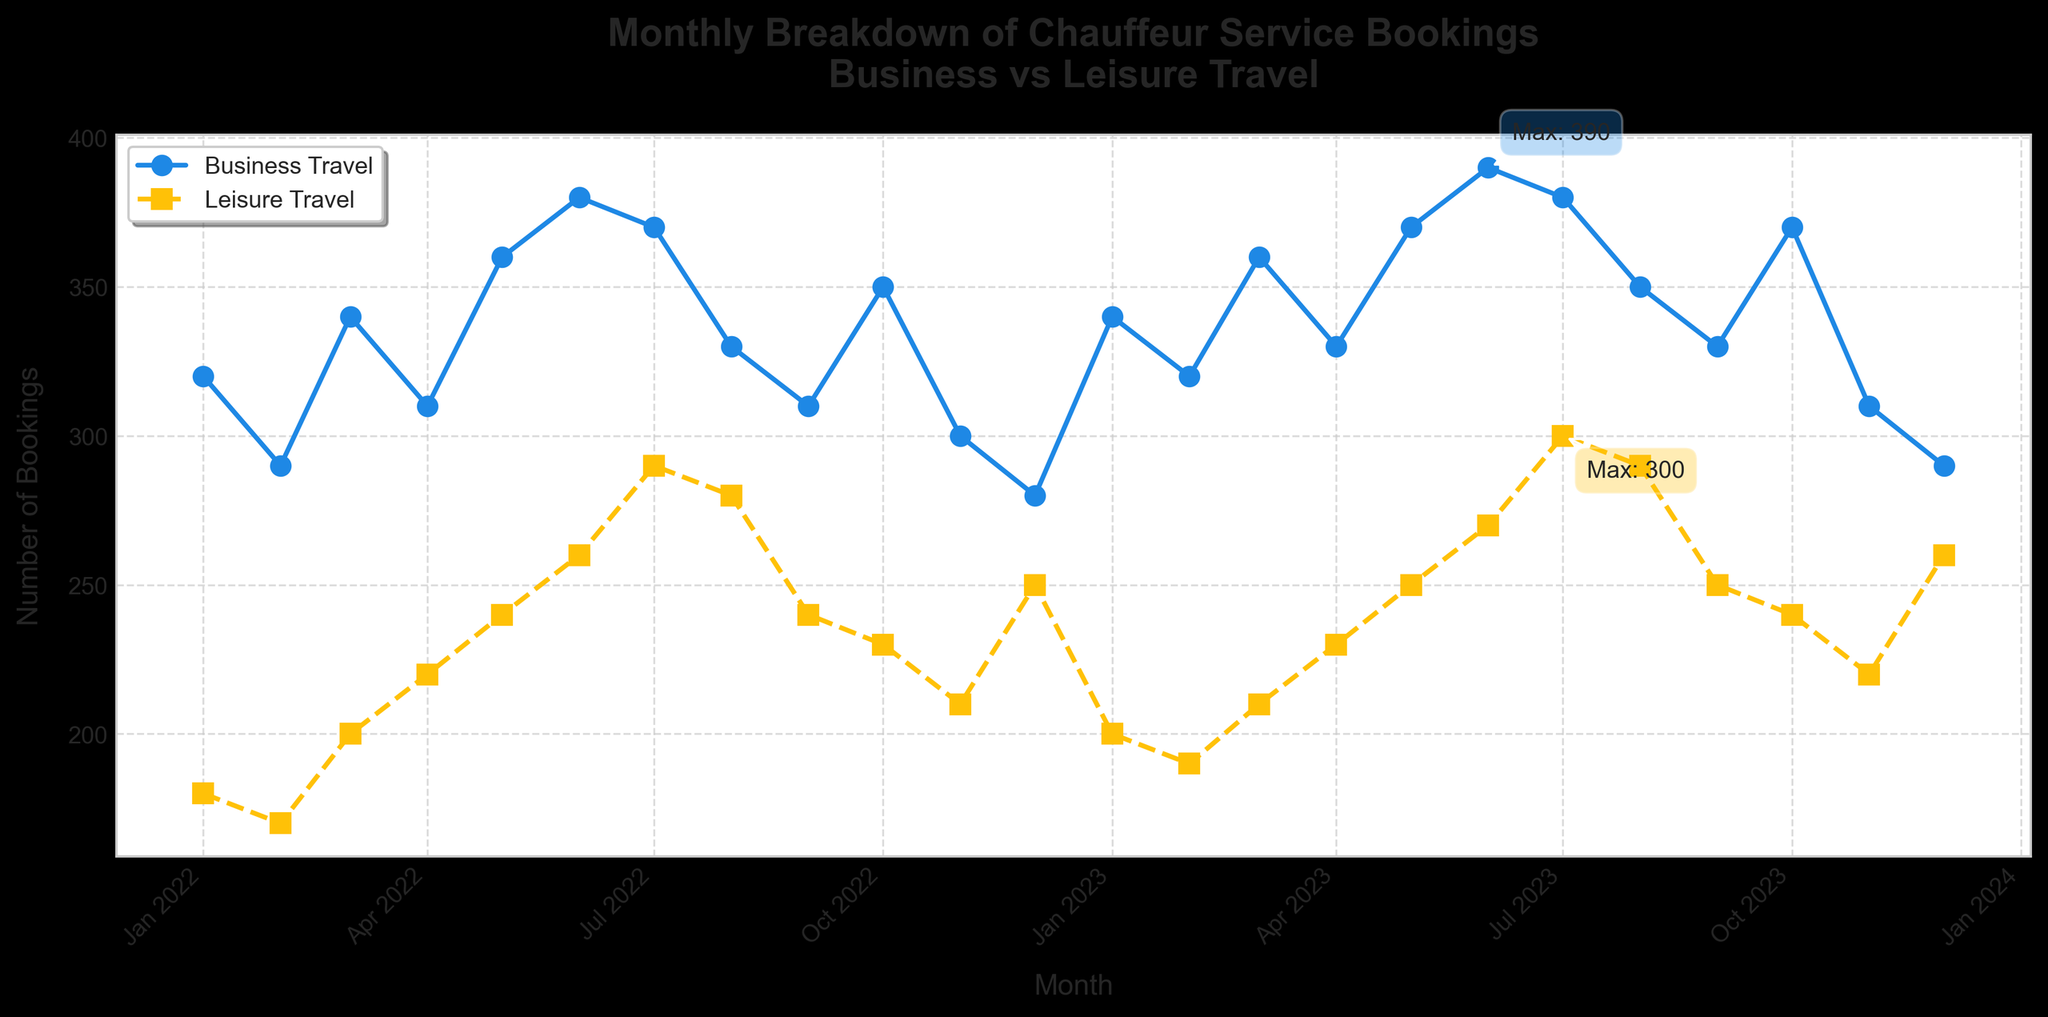What is the title of the plot? The title of the plot is displayed at the top center of the figure. It reads "Monthly Breakdown of Chauffeur Service Bookings\nBusiness vs Leisure Travel".
Answer: Monthly Breakdown of Chauffeur Service Bookings\nBusiness vs Leisure Travel What is the highest number of Business Travel bookings recorded in a month? By observing the annotations on the plot, we can see the highest point labeled "Max" for Business Travel. The highest number of bookings is 390.
Answer: 390 Which month and year had the maximum Leisure Travel bookings and what was the number? The annotation near one of the points indicates the maximum Leisure Travel bookings. The month and year are July 2023 and the number is 300.
Answer: July 2023, 300 How do the trends in Business Travel bookings compare to Leisure Travel bookings over time? By visually comparing the line plots, we see that Business Travel bookings are generally higher than Leisure Travel bookings. Both show a similar upward trend during mid-2022 to mid-2023, with Business Travel consistently having higher fluctuations.
Answer: Business Travel consistently higher, both show upward trends In which months of 2022 were Leisure Travel bookings higher than Business Travel bookings? By closely examining the plot where both lines are compared, Leisure Travel briefly surpasses Business Travel only in July 2022.
Answer: July 2022 What is the average number of Business Travel bookings for the year 2022? We add the Business Travel bookings for each month of 2022 and divide by 12 (320 + 290 + 340 + 310 + 360 + 380 + 370 + 330 + 310 + 350 + 300 + 280) / 12 = 6840 / 12 = 570.
Answer: 570 Which month had the lowest number of Business Travel bookings over the entire period shown? By scanning the Business Travel line, the lowest point corresponds to December 2023 with 290 bookings.
Answer: December 2023 During which period did Business Travel and Leisure Travel both show a decline? Both line plots show a declining trend from August 2022 to December 2022.
Answer: August 2022 to December 2022 In what month and year did Business Travel bookings reach their peak, and how does this compare to the same month's Leisure Travel bookings? Business Travel bookings peak in June 2023 with 390 bookings. For the same month, Leisure Travel bookings were 270.
Answer: June 2023; Business 390, Leisure 270 What is the difference in the number of Business Travel and Leisure Travel bookings in May 2023? For May 2023, Business Travel bookings were 370 and Leisure Travel bookings were 250. The difference is 370 - 250 = 120.
Answer: 120 